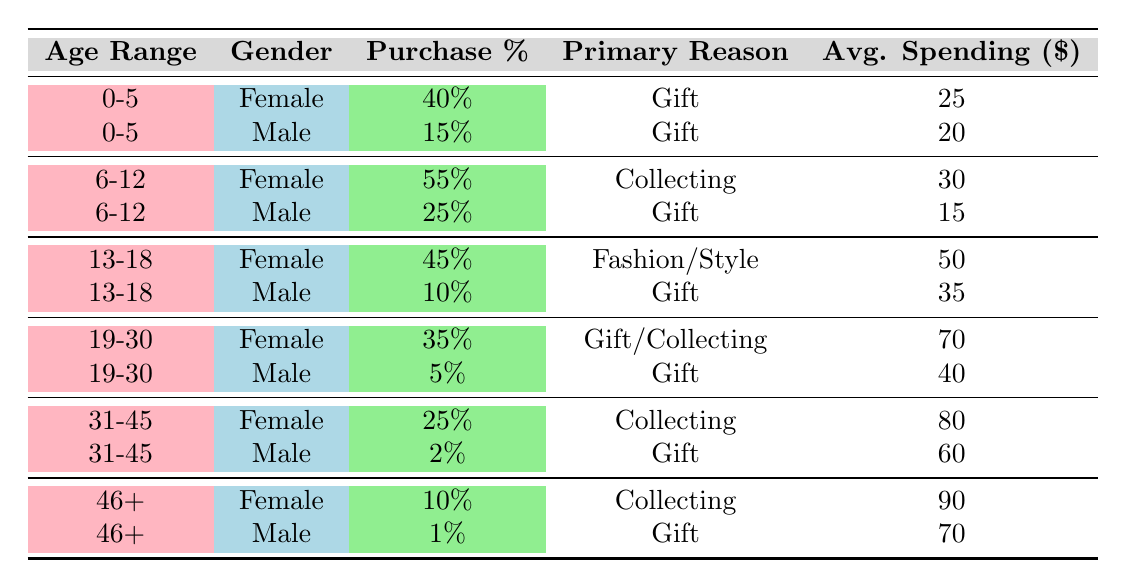What is the purchase percentage for females aged 0-5? In the table, locate the row with the age range "0-5" and gender "Female." The purchase percentage listed for this category is 40%.
Answer: 40% What is the average spending for males in the 31-45 age range? The table shows the relevant row for males aged "31-45," and the average spending listed in that row is 60 dollars.
Answer: 60 Which age range has the highest percentage of female purchasers? Examining the purchase percentages for the female category, the age range "6-12" has the highest at 55%.
Answer: 6-12 Is the primary reason for purchases among males aged 19-30 "Collecting"? Check the row for males aged "19-30." The primary reason stated in that row is "Gift," not "Collecting." Thus, the answer is no.
Answer: No What is the total purchase percentage for males across all age ranges? To find the total percentage, sum the purchase percentages of all male purchasers: 15 + 25 + 10 + 5 + 2 + 1 = 58.
Answer: 58 What is the average spending of female purchasers aged 13-18 compared to those aged 19-30? For females aged "13-18," the average spending is 50 dollars, and for those aged "19-30," it is 70 dollars. To find the average of both, calculate (50 + 70) / 2 = 60.
Answer: 60 Are there any male purchasers in the 46+ age range with a purchasing percentage greater than 5%? Reviewing the table, the purchasing percentage for males aged "46+" is 1%, which is not greater than 5%. The answer is no.
Answer: No What is the difference in average spending between females aged 31-45 and females aged 19-30? Locate the average spending for each: females aged "31-45" is 80 dollars and "19-30" is 70 dollars. The difference is 80 - 70 = 10 dollars.
Answer: 10 In which age range do males show the least purchase percentage? Looking through the purchase percentages for males, the "31-45" age range has the lowest at 2%.
Answer: 31-45 